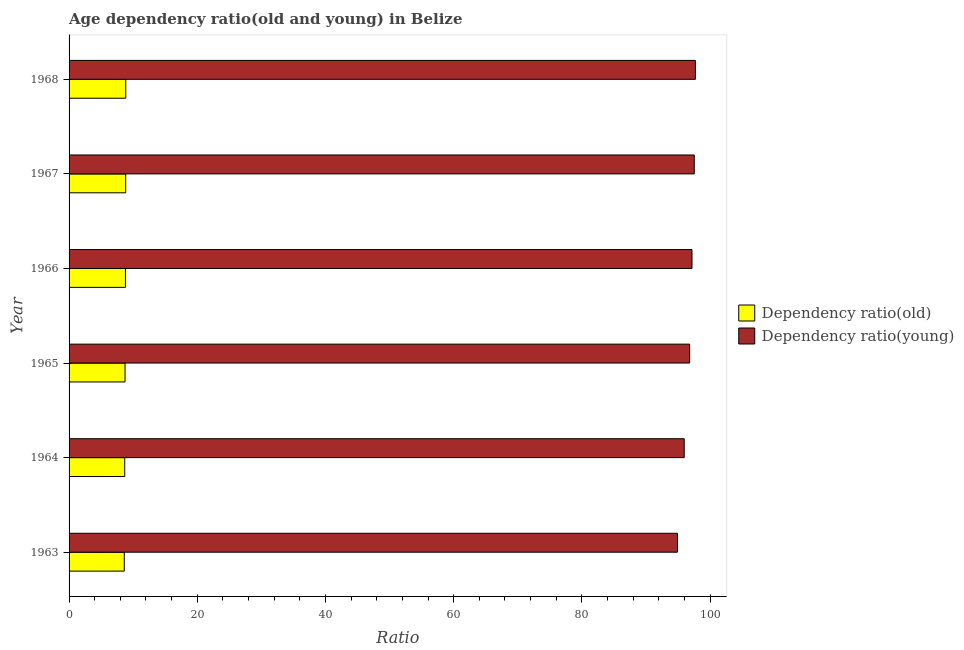How many different coloured bars are there?
Offer a very short reply. 2. Are the number of bars per tick equal to the number of legend labels?
Offer a very short reply. Yes. Are the number of bars on each tick of the Y-axis equal?
Provide a succinct answer. Yes. How many bars are there on the 3rd tick from the top?
Your answer should be very brief. 2. What is the label of the 1st group of bars from the top?
Your response must be concise. 1968. What is the age dependency ratio(young) in 1967?
Give a very brief answer. 97.53. Across all years, what is the maximum age dependency ratio(young)?
Your response must be concise. 97.71. Across all years, what is the minimum age dependency ratio(young)?
Your answer should be very brief. 94.91. In which year was the age dependency ratio(old) maximum?
Your answer should be very brief. 1968. In which year was the age dependency ratio(young) minimum?
Give a very brief answer. 1963. What is the total age dependency ratio(old) in the graph?
Provide a succinct answer. 52.5. What is the difference between the age dependency ratio(young) in 1963 and that in 1967?
Make the answer very short. -2.62. What is the difference between the age dependency ratio(old) in 1967 and the age dependency ratio(young) in 1964?
Provide a short and direct response. -87.14. What is the average age dependency ratio(young) per year?
Your answer should be compact. 96.69. In the year 1966, what is the difference between the age dependency ratio(old) and age dependency ratio(young)?
Your answer should be compact. -88.39. In how many years, is the age dependency ratio(young) greater than 8 ?
Provide a short and direct response. 6. What is the ratio of the age dependency ratio(young) in 1965 to that in 1966?
Provide a succinct answer. 1. Is the difference between the age dependency ratio(young) in 1966 and 1968 greater than the difference between the age dependency ratio(old) in 1966 and 1968?
Make the answer very short. No. What is the difference between the highest and the second highest age dependency ratio(young)?
Provide a short and direct response. 0.18. In how many years, is the age dependency ratio(old) greater than the average age dependency ratio(old) taken over all years?
Your response must be concise. 3. Is the sum of the age dependency ratio(young) in 1964 and 1967 greater than the maximum age dependency ratio(old) across all years?
Provide a short and direct response. Yes. What does the 1st bar from the top in 1964 represents?
Your response must be concise. Dependency ratio(young). What does the 1st bar from the bottom in 1966 represents?
Ensure brevity in your answer.  Dependency ratio(old). Are all the bars in the graph horizontal?
Keep it short and to the point. Yes. What is the difference between two consecutive major ticks on the X-axis?
Give a very brief answer. 20. Are the values on the major ticks of X-axis written in scientific E-notation?
Your response must be concise. No. Does the graph contain any zero values?
Provide a short and direct response. No. Where does the legend appear in the graph?
Offer a terse response. Center right. How many legend labels are there?
Provide a succinct answer. 2. How are the legend labels stacked?
Offer a very short reply. Vertical. What is the title of the graph?
Offer a terse response. Age dependency ratio(old and young) in Belize. What is the label or title of the X-axis?
Give a very brief answer. Ratio. What is the Ratio in Dependency ratio(old) in 1963?
Provide a short and direct response. 8.61. What is the Ratio in Dependency ratio(young) in 1963?
Your answer should be very brief. 94.91. What is the Ratio in Dependency ratio(old) in 1964?
Your response must be concise. 8.68. What is the Ratio of Dependency ratio(young) in 1964?
Your answer should be very brief. 95.97. What is the Ratio of Dependency ratio(old) in 1965?
Your answer should be very brief. 8.73. What is the Ratio in Dependency ratio(young) in 1965?
Offer a very short reply. 96.81. What is the Ratio of Dependency ratio(old) in 1966?
Your answer should be compact. 8.8. What is the Ratio of Dependency ratio(young) in 1966?
Offer a terse response. 97.18. What is the Ratio of Dependency ratio(old) in 1967?
Give a very brief answer. 8.83. What is the Ratio of Dependency ratio(young) in 1967?
Offer a terse response. 97.53. What is the Ratio in Dependency ratio(old) in 1968?
Ensure brevity in your answer.  8.85. What is the Ratio of Dependency ratio(young) in 1968?
Give a very brief answer. 97.71. Across all years, what is the maximum Ratio of Dependency ratio(old)?
Offer a very short reply. 8.85. Across all years, what is the maximum Ratio of Dependency ratio(young)?
Keep it short and to the point. 97.71. Across all years, what is the minimum Ratio in Dependency ratio(old)?
Ensure brevity in your answer.  8.61. Across all years, what is the minimum Ratio in Dependency ratio(young)?
Your answer should be very brief. 94.91. What is the total Ratio of Dependency ratio(old) in the graph?
Your answer should be very brief. 52.5. What is the total Ratio of Dependency ratio(young) in the graph?
Offer a very short reply. 580.12. What is the difference between the Ratio in Dependency ratio(old) in 1963 and that in 1964?
Provide a short and direct response. -0.07. What is the difference between the Ratio of Dependency ratio(young) in 1963 and that in 1964?
Ensure brevity in your answer.  -1.06. What is the difference between the Ratio of Dependency ratio(old) in 1963 and that in 1965?
Give a very brief answer. -0.12. What is the difference between the Ratio of Dependency ratio(young) in 1963 and that in 1965?
Make the answer very short. -1.9. What is the difference between the Ratio of Dependency ratio(old) in 1963 and that in 1966?
Your response must be concise. -0.18. What is the difference between the Ratio of Dependency ratio(young) in 1963 and that in 1966?
Ensure brevity in your answer.  -2.27. What is the difference between the Ratio in Dependency ratio(old) in 1963 and that in 1967?
Make the answer very short. -0.22. What is the difference between the Ratio of Dependency ratio(young) in 1963 and that in 1967?
Offer a terse response. -2.62. What is the difference between the Ratio of Dependency ratio(old) in 1963 and that in 1968?
Your answer should be compact. -0.23. What is the difference between the Ratio in Dependency ratio(young) in 1963 and that in 1968?
Your answer should be very brief. -2.8. What is the difference between the Ratio in Dependency ratio(old) in 1964 and that in 1965?
Give a very brief answer. -0.04. What is the difference between the Ratio of Dependency ratio(young) in 1964 and that in 1965?
Your answer should be compact. -0.84. What is the difference between the Ratio in Dependency ratio(old) in 1964 and that in 1966?
Give a very brief answer. -0.11. What is the difference between the Ratio of Dependency ratio(young) in 1964 and that in 1966?
Your response must be concise. -1.21. What is the difference between the Ratio in Dependency ratio(old) in 1964 and that in 1967?
Offer a terse response. -0.15. What is the difference between the Ratio in Dependency ratio(young) in 1964 and that in 1967?
Your response must be concise. -1.56. What is the difference between the Ratio in Dependency ratio(old) in 1964 and that in 1968?
Make the answer very short. -0.16. What is the difference between the Ratio in Dependency ratio(young) in 1964 and that in 1968?
Ensure brevity in your answer.  -1.74. What is the difference between the Ratio in Dependency ratio(old) in 1965 and that in 1966?
Offer a terse response. -0.07. What is the difference between the Ratio in Dependency ratio(young) in 1965 and that in 1966?
Make the answer very short. -0.37. What is the difference between the Ratio of Dependency ratio(old) in 1965 and that in 1967?
Your answer should be very brief. -0.1. What is the difference between the Ratio in Dependency ratio(young) in 1965 and that in 1967?
Keep it short and to the point. -0.72. What is the difference between the Ratio in Dependency ratio(old) in 1965 and that in 1968?
Provide a succinct answer. -0.12. What is the difference between the Ratio in Dependency ratio(young) in 1965 and that in 1968?
Your answer should be compact. -0.9. What is the difference between the Ratio in Dependency ratio(old) in 1966 and that in 1967?
Make the answer very short. -0.04. What is the difference between the Ratio in Dependency ratio(young) in 1966 and that in 1967?
Offer a terse response. -0.35. What is the difference between the Ratio in Dependency ratio(old) in 1966 and that in 1968?
Give a very brief answer. -0.05. What is the difference between the Ratio in Dependency ratio(young) in 1966 and that in 1968?
Provide a succinct answer. -0.53. What is the difference between the Ratio of Dependency ratio(old) in 1967 and that in 1968?
Make the answer very short. -0.01. What is the difference between the Ratio in Dependency ratio(young) in 1967 and that in 1968?
Ensure brevity in your answer.  -0.18. What is the difference between the Ratio in Dependency ratio(old) in 1963 and the Ratio in Dependency ratio(young) in 1964?
Make the answer very short. -87.36. What is the difference between the Ratio of Dependency ratio(old) in 1963 and the Ratio of Dependency ratio(young) in 1965?
Your answer should be compact. -88.2. What is the difference between the Ratio of Dependency ratio(old) in 1963 and the Ratio of Dependency ratio(young) in 1966?
Your answer should be compact. -88.57. What is the difference between the Ratio in Dependency ratio(old) in 1963 and the Ratio in Dependency ratio(young) in 1967?
Make the answer very short. -88.92. What is the difference between the Ratio in Dependency ratio(old) in 1963 and the Ratio in Dependency ratio(young) in 1968?
Keep it short and to the point. -89.1. What is the difference between the Ratio in Dependency ratio(old) in 1964 and the Ratio in Dependency ratio(young) in 1965?
Make the answer very short. -88.13. What is the difference between the Ratio in Dependency ratio(old) in 1964 and the Ratio in Dependency ratio(young) in 1966?
Give a very brief answer. -88.5. What is the difference between the Ratio in Dependency ratio(old) in 1964 and the Ratio in Dependency ratio(young) in 1967?
Make the answer very short. -88.85. What is the difference between the Ratio of Dependency ratio(old) in 1964 and the Ratio of Dependency ratio(young) in 1968?
Provide a short and direct response. -89.03. What is the difference between the Ratio in Dependency ratio(old) in 1965 and the Ratio in Dependency ratio(young) in 1966?
Keep it short and to the point. -88.45. What is the difference between the Ratio in Dependency ratio(old) in 1965 and the Ratio in Dependency ratio(young) in 1967?
Give a very brief answer. -88.8. What is the difference between the Ratio of Dependency ratio(old) in 1965 and the Ratio of Dependency ratio(young) in 1968?
Your response must be concise. -88.98. What is the difference between the Ratio of Dependency ratio(old) in 1966 and the Ratio of Dependency ratio(young) in 1967?
Your response must be concise. -88.74. What is the difference between the Ratio of Dependency ratio(old) in 1966 and the Ratio of Dependency ratio(young) in 1968?
Give a very brief answer. -88.92. What is the difference between the Ratio in Dependency ratio(old) in 1967 and the Ratio in Dependency ratio(young) in 1968?
Your response must be concise. -88.88. What is the average Ratio of Dependency ratio(old) per year?
Provide a succinct answer. 8.75. What is the average Ratio of Dependency ratio(young) per year?
Offer a terse response. 96.69. In the year 1963, what is the difference between the Ratio in Dependency ratio(old) and Ratio in Dependency ratio(young)?
Provide a succinct answer. -86.3. In the year 1964, what is the difference between the Ratio of Dependency ratio(old) and Ratio of Dependency ratio(young)?
Offer a very short reply. -87.28. In the year 1965, what is the difference between the Ratio of Dependency ratio(old) and Ratio of Dependency ratio(young)?
Your response must be concise. -88.08. In the year 1966, what is the difference between the Ratio in Dependency ratio(old) and Ratio in Dependency ratio(young)?
Give a very brief answer. -88.38. In the year 1967, what is the difference between the Ratio of Dependency ratio(old) and Ratio of Dependency ratio(young)?
Provide a short and direct response. -88.7. In the year 1968, what is the difference between the Ratio in Dependency ratio(old) and Ratio in Dependency ratio(young)?
Offer a terse response. -88.87. What is the ratio of the Ratio of Dependency ratio(old) in 1963 to that in 1964?
Provide a succinct answer. 0.99. What is the ratio of the Ratio in Dependency ratio(young) in 1963 to that in 1964?
Offer a very short reply. 0.99. What is the ratio of the Ratio in Dependency ratio(old) in 1963 to that in 1965?
Your answer should be compact. 0.99. What is the ratio of the Ratio of Dependency ratio(young) in 1963 to that in 1965?
Give a very brief answer. 0.98. What is the ratio of the Ratio in Dependency ratio(old) in 1963 to that in 1966?
Offer a terse response. 0.98. What is the ratio of the Ratio in Dependency ratio(young) in 1963 to that in 1966?
Offer a very short reply. 0.98. What is the ratio of the Ratio of Dependency ratio(old) in 1963 to that in 1967?
Your answer should be very brief. 0.98. What is the ratio of the Ratio in Dependency ratio(young) in 1963 to that in 1967?
Keep it short and to the point. 0.97. What is the ratio of the Ratio of Dependency ratio(old) in 1963 to that in 1968?
Make the answer very short. 0.97. What is the ratio of the Ratio in Dependency ratio(young) in 1963 to that in 1968?
Provide a short and direct response. 0.97. What is the ratio of the Ratio in Dependency ratio(old) in 1964 to that in 1965?
Make the answer very short. 0.99. What is the ratio of the Ratio of Dependency ratio(young) in 1964 to that in 1965?
Make the answer very short. 0.99. What is the ratio of the Ratio in Dependency ratio(old) in 1964 to that in 1966?
Your answer should be very brief. 0.99. What is the ratio of the Ratio in Dependency ratio(young) in 1964 to that in 1966?
Your answer should be very brief. 0.99. What is the ratio of the Ratio of Dependency ratio(old) in 1964 to that in 1967?
Your response must be concise. 0.98. What is the ratio of the Ratio of Dependency ratio(old) in 1964 to that in 1968?
Provide a short and direct response. 0.98. What is the ratio of the Ratio in Dependency ratio(young) in 1964 to that in 1968?
Keep it short and to the point. 0.98. What is the ratio of the Ratio of Dependency ratio(old) in 1965 to that in 1967?
Your answer should be very brief. 0.99. What is the ratio of the Ratio in Dependency ratio(young) in 1965 to that in 1967?
Ensure brevity in your answer.  0.99. What is the ratio of the Ratio of Dependency ratio(old) in 1965 to that in 1968?
Your answer should be compact. 0.99. What is the ratio of the Ratio of Dependency ratio(old) in 1966 to that in 1967?
Provide a short and direct response. 1. What is the ratio of the Ratio in Dependency ratio(young) in 1966 to that in 1967?
Make the answer very short. 1. What is the ratio of the Ratio in Dependency ratio(old) in 1966 to that in 1968?
Offer a very short reply. 0.99. What is the ratio of the Ratio of Dependency ratio(young) in 1966 to that in 1968?
Ensure brevity in your answer.  0.99. What is the ratio of the Ratio of Dependency ratio(old) in 1967 to that in 1968?
Your answer should be compact. 1. What is the difference between the highest and the second highest Ratio of Dependency ratio(old)?
Ensure brevity in your answer.  0.01. What is the difference between the highest and the second highest Ratio in Dependency ratio(young)?
Offer a terse response. 0.18. What is the difference between the highest and the lowest Ratio of Dependency ratio(old)?
Ensure brevity in your answer.  0.23. What is the difference between the highest and the lowest Ratio of Dependency ratio(young)?
Give a very brief answer. 2.8. 